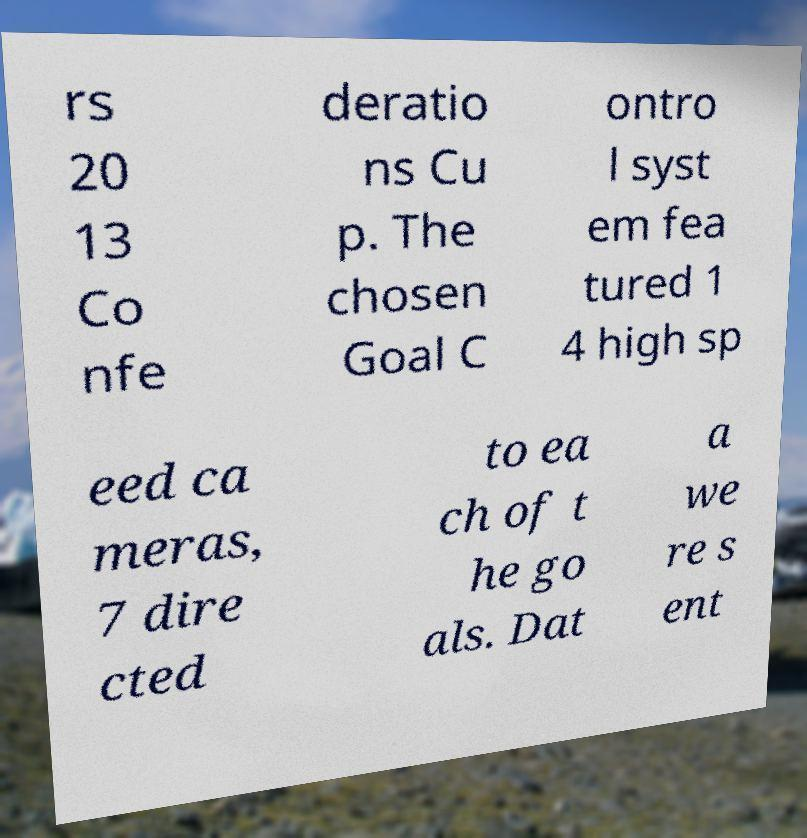Can you accurately transcribe the text from the provided image for me? rs 20 13 Co nfe deratio ns Cu p. The chosen Goal C ontro l syst em fea tured 1 4 high sp eed ca meras, 7 dire cted to ea ch of t he go als. Dat a we re s ent 